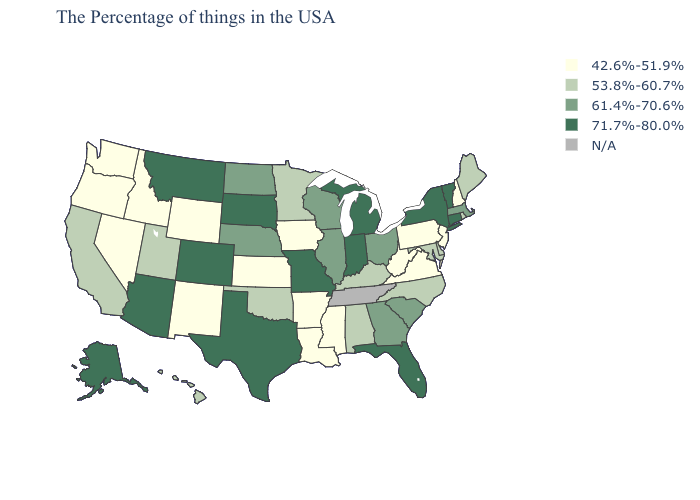What is the value of Oklahoma?
Concise answer only. 53.8%-60.7%. Name the states that have a value in the range 42.6%-51.9%?
Be succinct. New Hampshire, New Jersey, Pennsylvania, Virginia, West Virginia, Mississippi, Louisiana, Arkansas, Iowa, Kansas, Wyoming, New Mexico, Idaho, Nevada, Washington, Oregon. Does California have the highest value in the West?
Quick response, please. No. Is the legend a continuous bar?
Write a very short answer. No. Name the states that have a value in the range 42.6%-51.9%?
Short answer required. New Hampshire, New Jersey, Pennsylvania, Virginia, West Virginia, Mississippi, Louisiana, Arkansas, Iowa, Kansas, Wyoming, New Mexico, Idaho, Nevada, Washington, Oregon. Does Hawaii have the lowest value in the West?
Keep it brief. No. What is the value of South Carolina?
Keep it brief. 61.4%-70.6%. Name the states that have a value in the range 61.4%-70.6%?
Give a very brief answer. Massachusetts, South Carolina, Ohio, Georgia, Wisconsin, Illinois, Nebraska, North Dakota. What is the value of New Hampshire?
Give a very brief answer. 42.6%-51.9%. Name the states that have a value in the range 71.7%-80.0%?
Keep it brief. Vermont, Connecticut, New York, Florida, Michigan, Indiana, Missouri, Texas, South Dakota, Colorado, Montana, Arizona, Alaska. Does the first symbol in the legend represent the smallest category?
Be succinct. Yes. What is the lowest value in states that border Iowa?
Answer briefly. 53.8%-60.7%. Does New York have the lowest value in the Northeast?
Answer briefly. No. Which states have the lowest value in the USA?
Short answer required. New Hampshire, New Jersey, Pennsylvania, Virginia, West Virginia, Mississippi, Louisiana, Arkansas, Iowa, Kansas, Wyoming, New Mexico, Idaho, Nevada, Washington, Oregon. Among the states that border South Dakota , which have the highest value?
Quick response, please. Montana. 